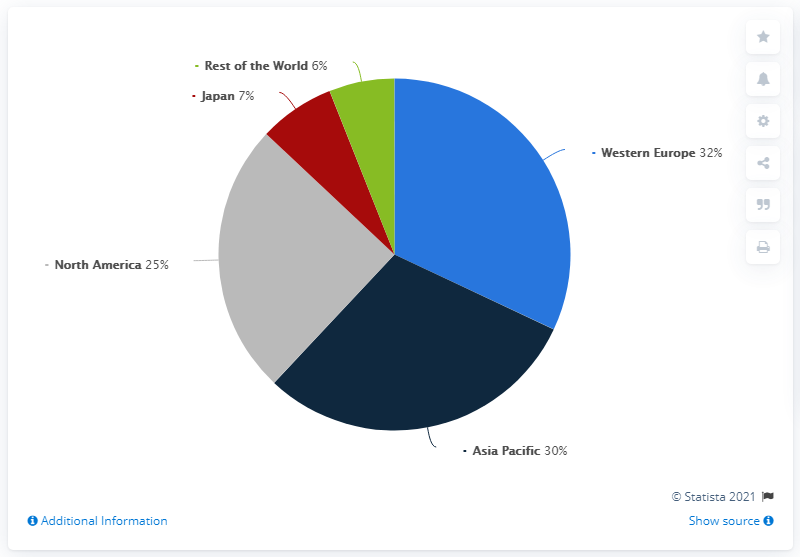Give some essential details in this illustration. The difference between the 'Japan' and 'Rest of the World' segments is the smallest. The angles created by the segments of Japan and the Rest of the World are 3.6 degrees. 